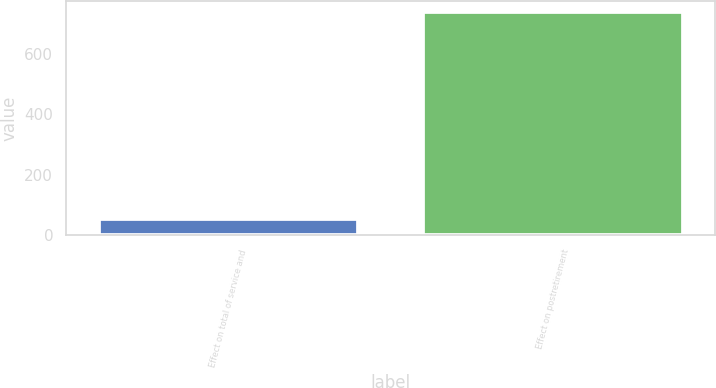<chart> <loc_0><loc_0><loc_500><loc_500><bar_chart><fcel>Effect on total of service and<fcel>Effect on postretirement<nl><fcel>54<fcel>736<nl></chart> 